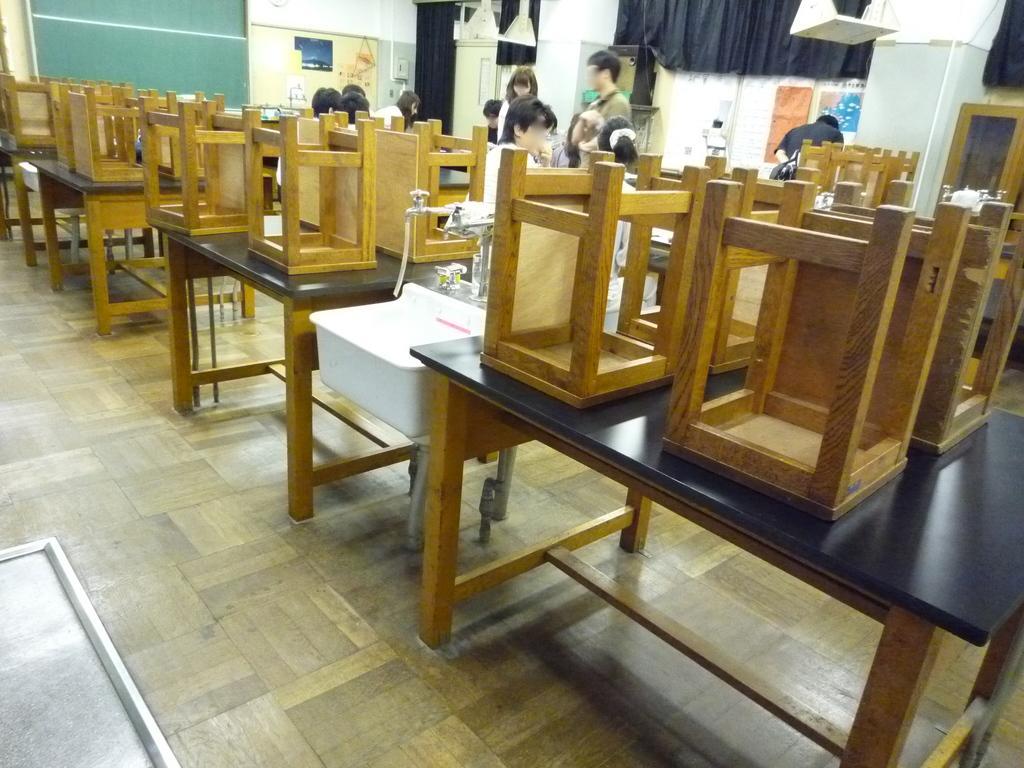In one or two sentences, can you explain what this image depicts? In this image I can see some wooden tables and stools on them , aboard, a wash basin and a tap, I can see some people standing and some are sitting in a room. At the top of the image I can see some metal objects hanging. 